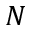Convert formula to latex. <formula><loc_0><loc_0><loc_500><loc_500>N</formula> 